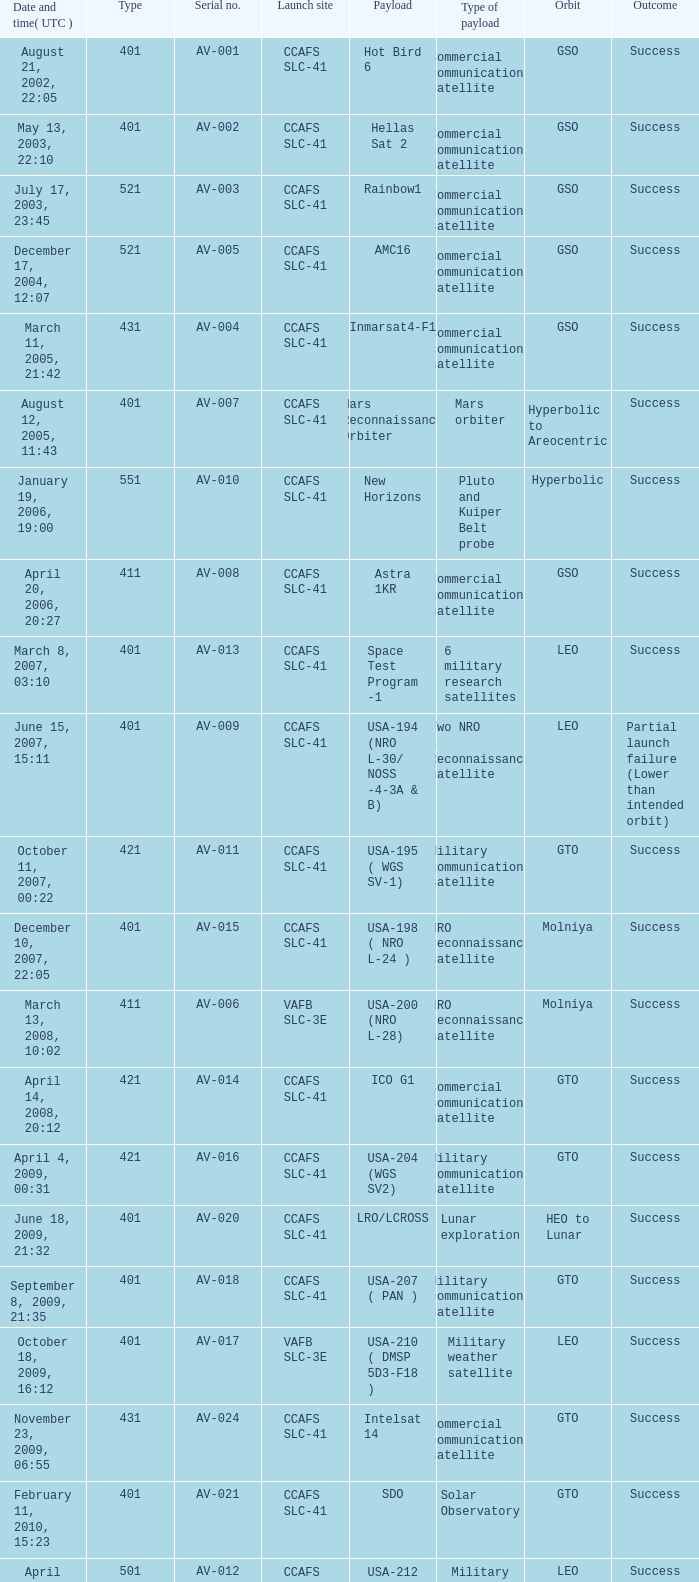When was the payload of Commercial Communications Satellite amc16? December 17, 2004, 12:07. 